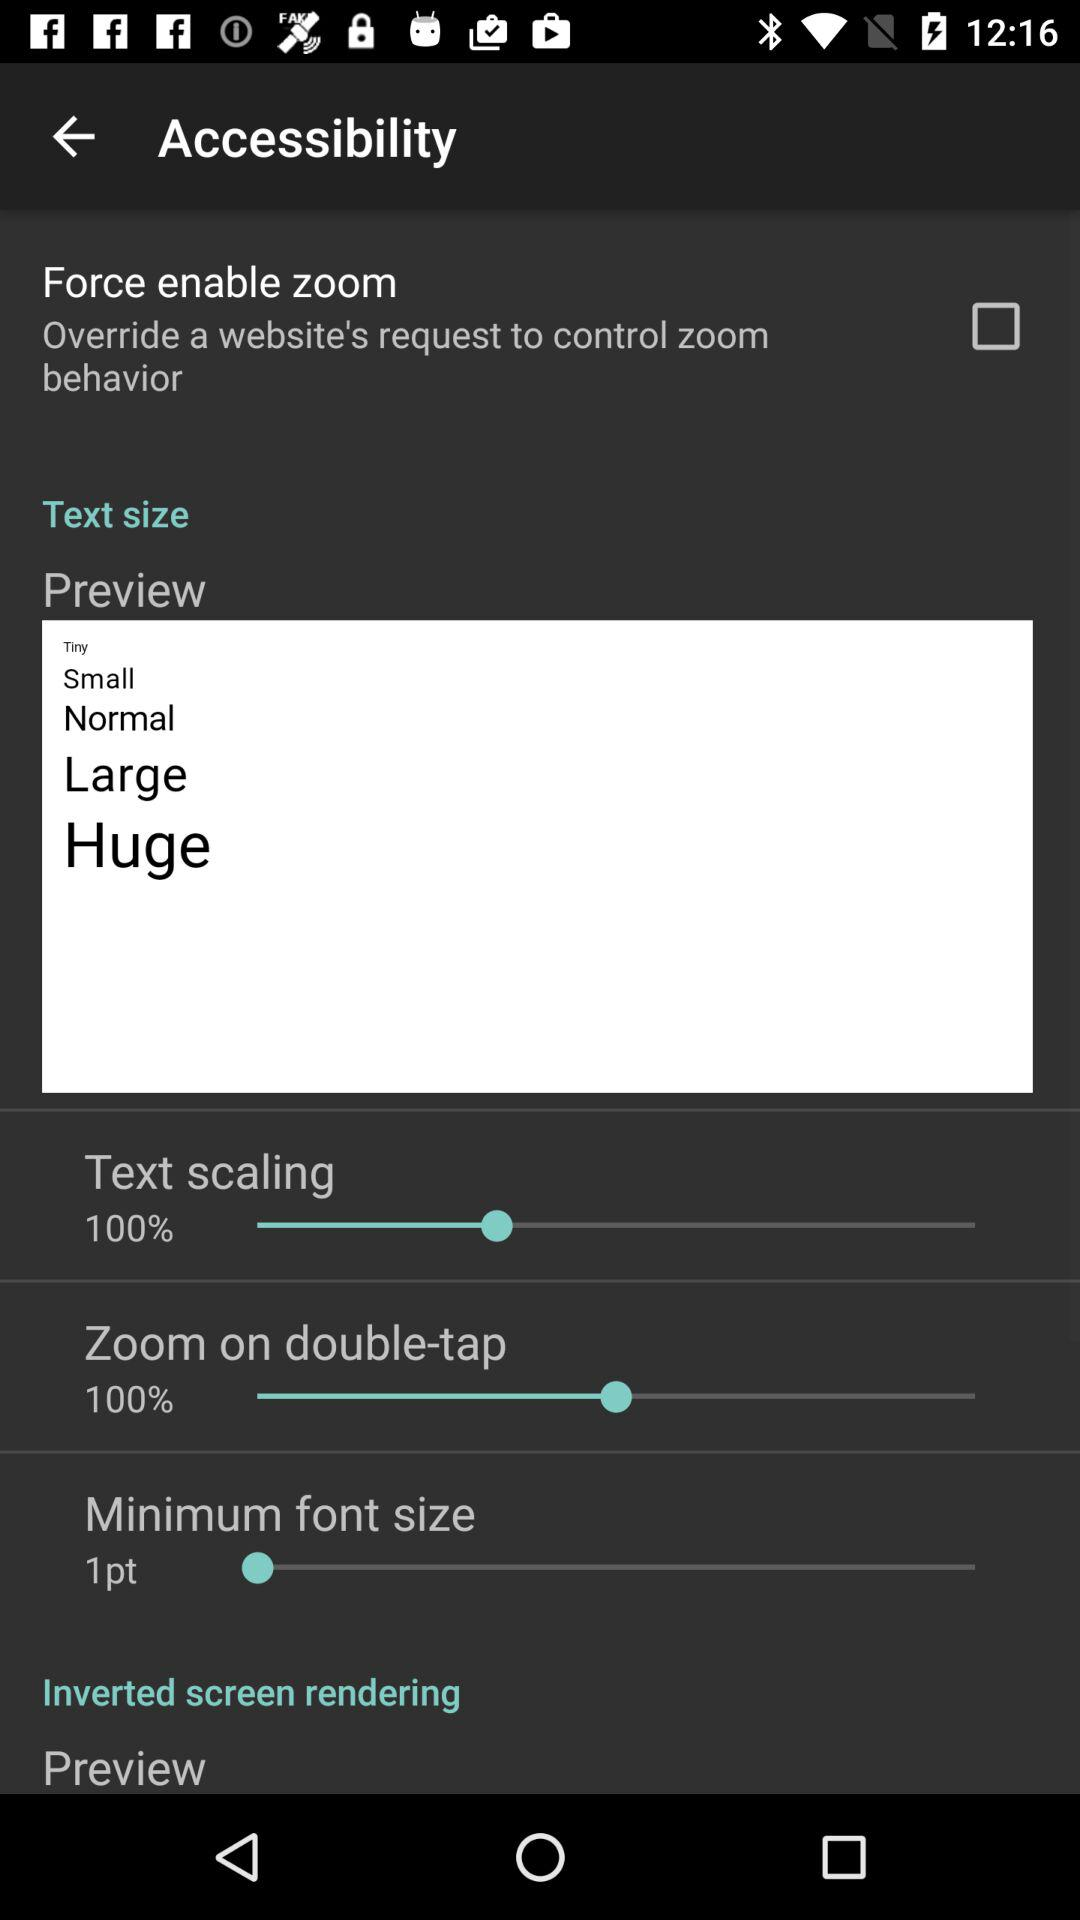What is the zoom percentage on double-tap? The zoom percentage on double-tap is 100%. 